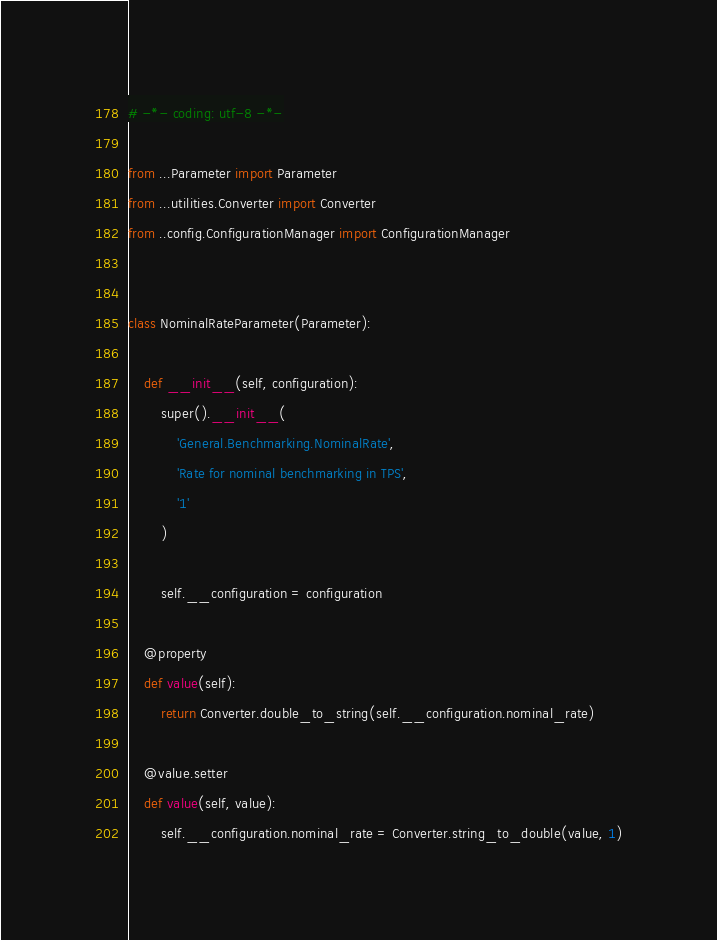Convert code to text. <code><loc_0><loc_0><loc_500><loc_500><_Python_># -*- coding: utf-8 -*-

from ...Parameter import Parameter
from ...utilities.Converter import Converter
from ..config.ConfigurationManager import ConfigurationManager


class NominalRateParameter(Parameter):

    def __init__(self, configuration):
        super().__init__(
            'General.Benchmarking.NominalRate',
            'Rate for nominal benchmarking in TPS',
            '1'
        )

        self.__configuration = configuration

    @property
    def value(self):
        return Converter.double_to_string(self.__configuration.nominal_rate)

    @value.setter
    def value(self, value):
        self.__configuration.nominal_rate = Converter.string_to_double(value, 1)
</code> 